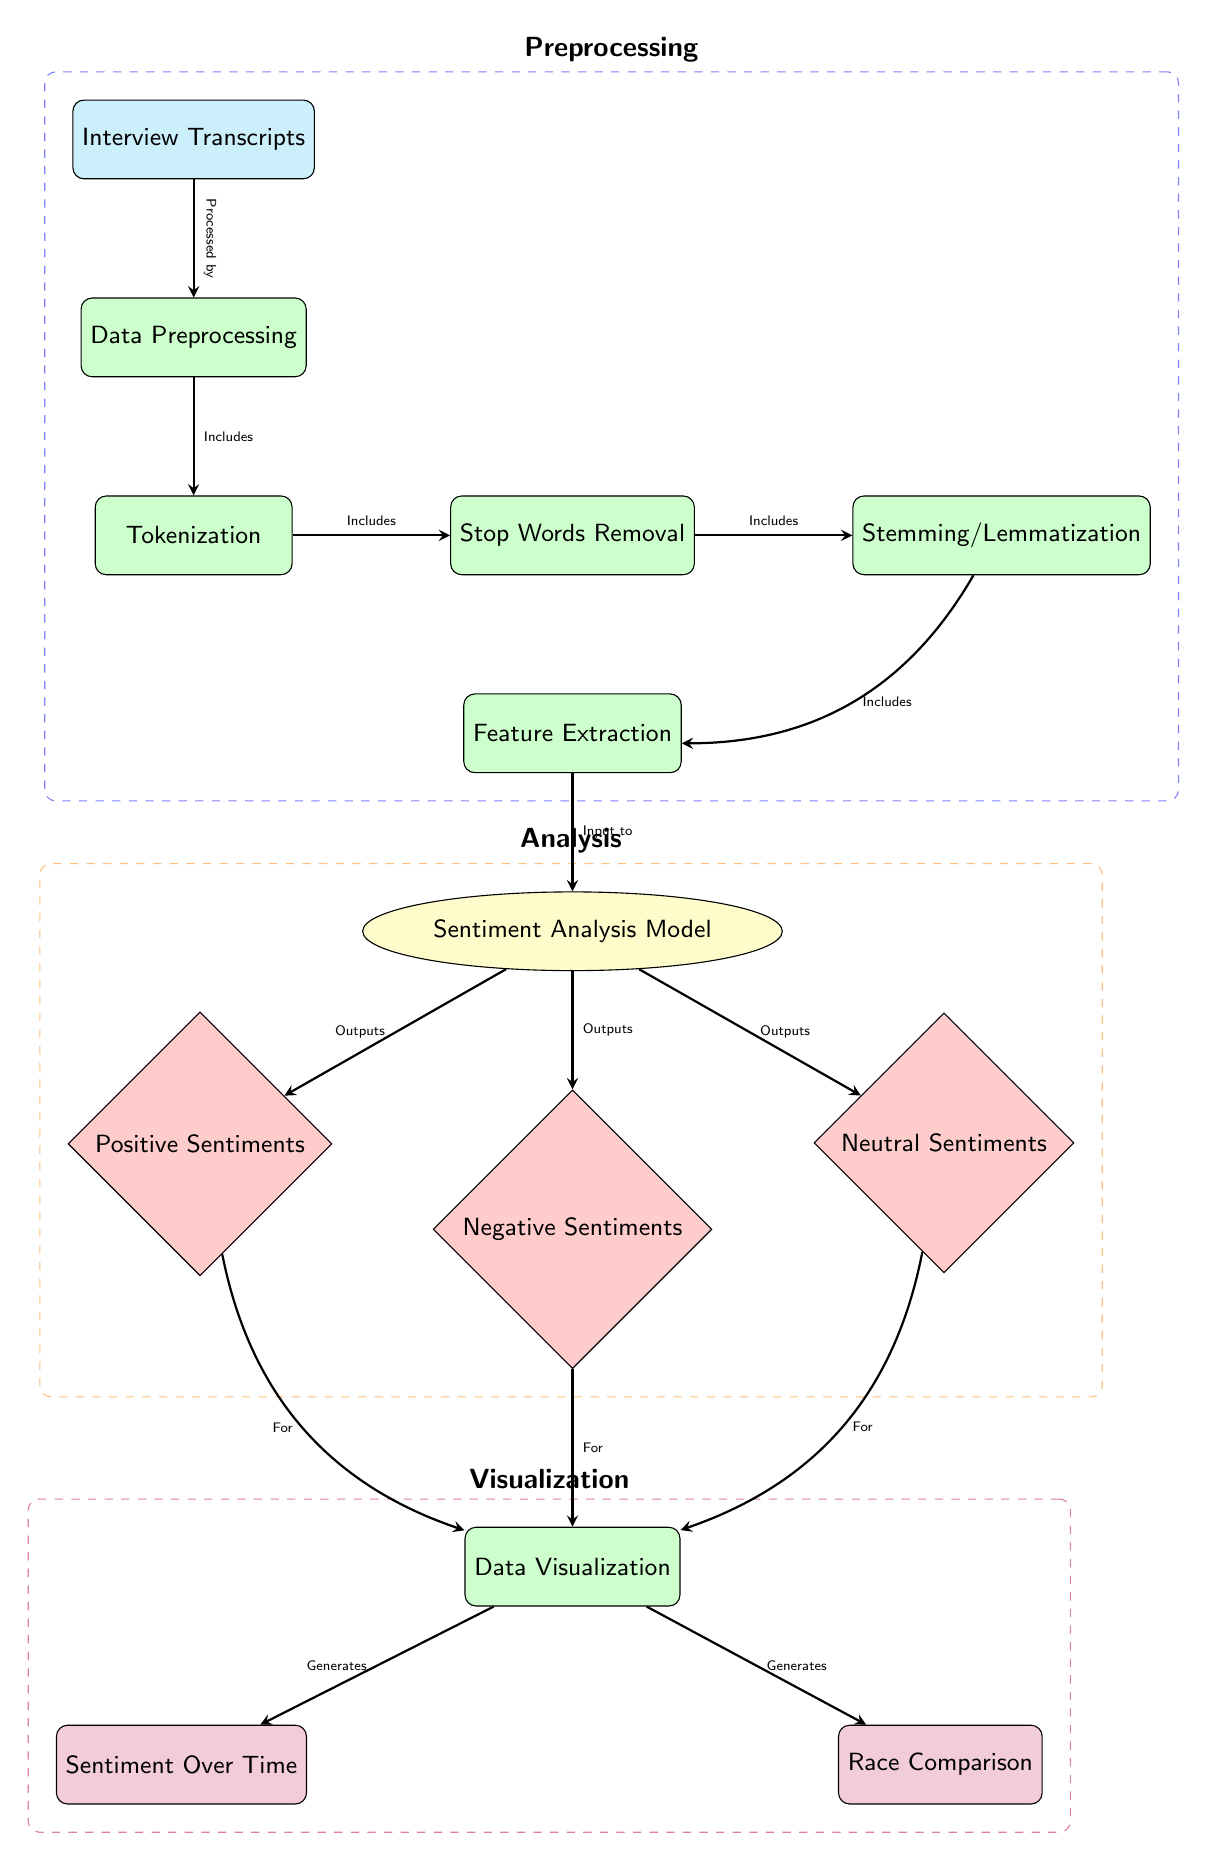What is the initial data source in this diagram? The diagram starts with the "Interview Transcripts" node as the initial data source.
Answer: Interview Transcripts How many types of sentiments are outputted by the sentiment analysis model? The diagram indicates there are three types of sentiments outputted: Positive Sentiments, Negative Sentiments, and Neutral Sentiments.
Answer: Three What process comes immediately after Data Preprocessing? The diagram shows that "Tokenization" is the process that comes immediately after "Data Preprocessing."
Answer: Tokenization Which process involves removing common words that do not contribute meaningfully to the sentiment analysis? The "Stop Words Removal" process is responsible for removing common words that don't add meaningful context to the sentiment analysis.
Answer: Stop Words Removal How many processes are involved before feature extraction? There are four processes involved before "Feature Extraction": Data Preprocessing, Tokenization, Stop Words Removal, and Stemming/Lemmatization.
Answer: Four What generates the "Sentiment Over Time" visualization? The "Data Visualization" process generates the "Sentiment Over Time" visualization, which is based on the outputs from the sentiment analysis model.
Answer: Data Visualization Which node is directly connected to both Negative Sentiments and Neutral Sentiments outputs? The "Sentiment Analysis Model" node is directly connected to both Negative Sentiments and Neutral Sentiments.
Answer: Sentiment Analysis Model What is the function of the "Feature Extraction" process in the diagram? "Feature Extraction" is the step where the relevant features from the tokenized data are pulled out to prepare it as input for the sentiment analysis model.
Answer: Input preparation Which visualization compares sentiments across different races? The visualization that compares sentiments across different races is labeled "Race Comparison."
Answer: Race Comparison 